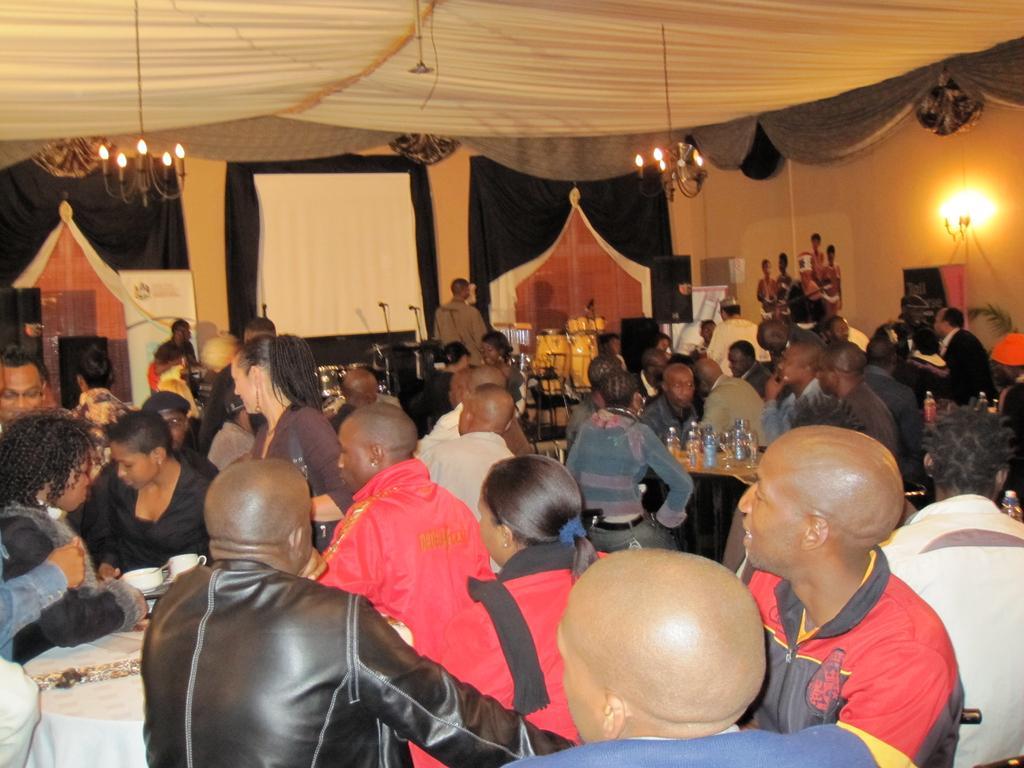Could you give a brief overview of what you see in this image? In this picture we can see there are groups of people sitting on chairs. In front of the people there are tables and on the tables, there are bottles, cups and glasses. Behind the people there are some objects. At the top of the image, there are chandeliers. On the right side of the image, there is a plant and light. 